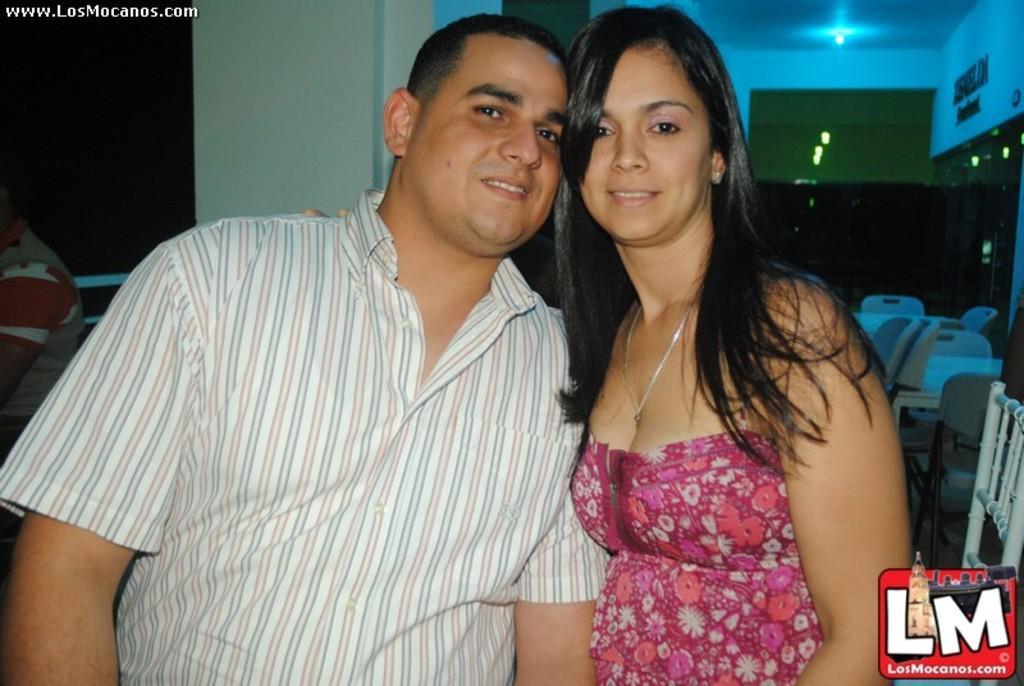How would you summarize this image in a sentence or two? 2 people are present. The person at the right is wearing a pink dress and a chain. The person at the left is wearing a white striped shirt. There are chairs at the back and there is another person at the left back. 